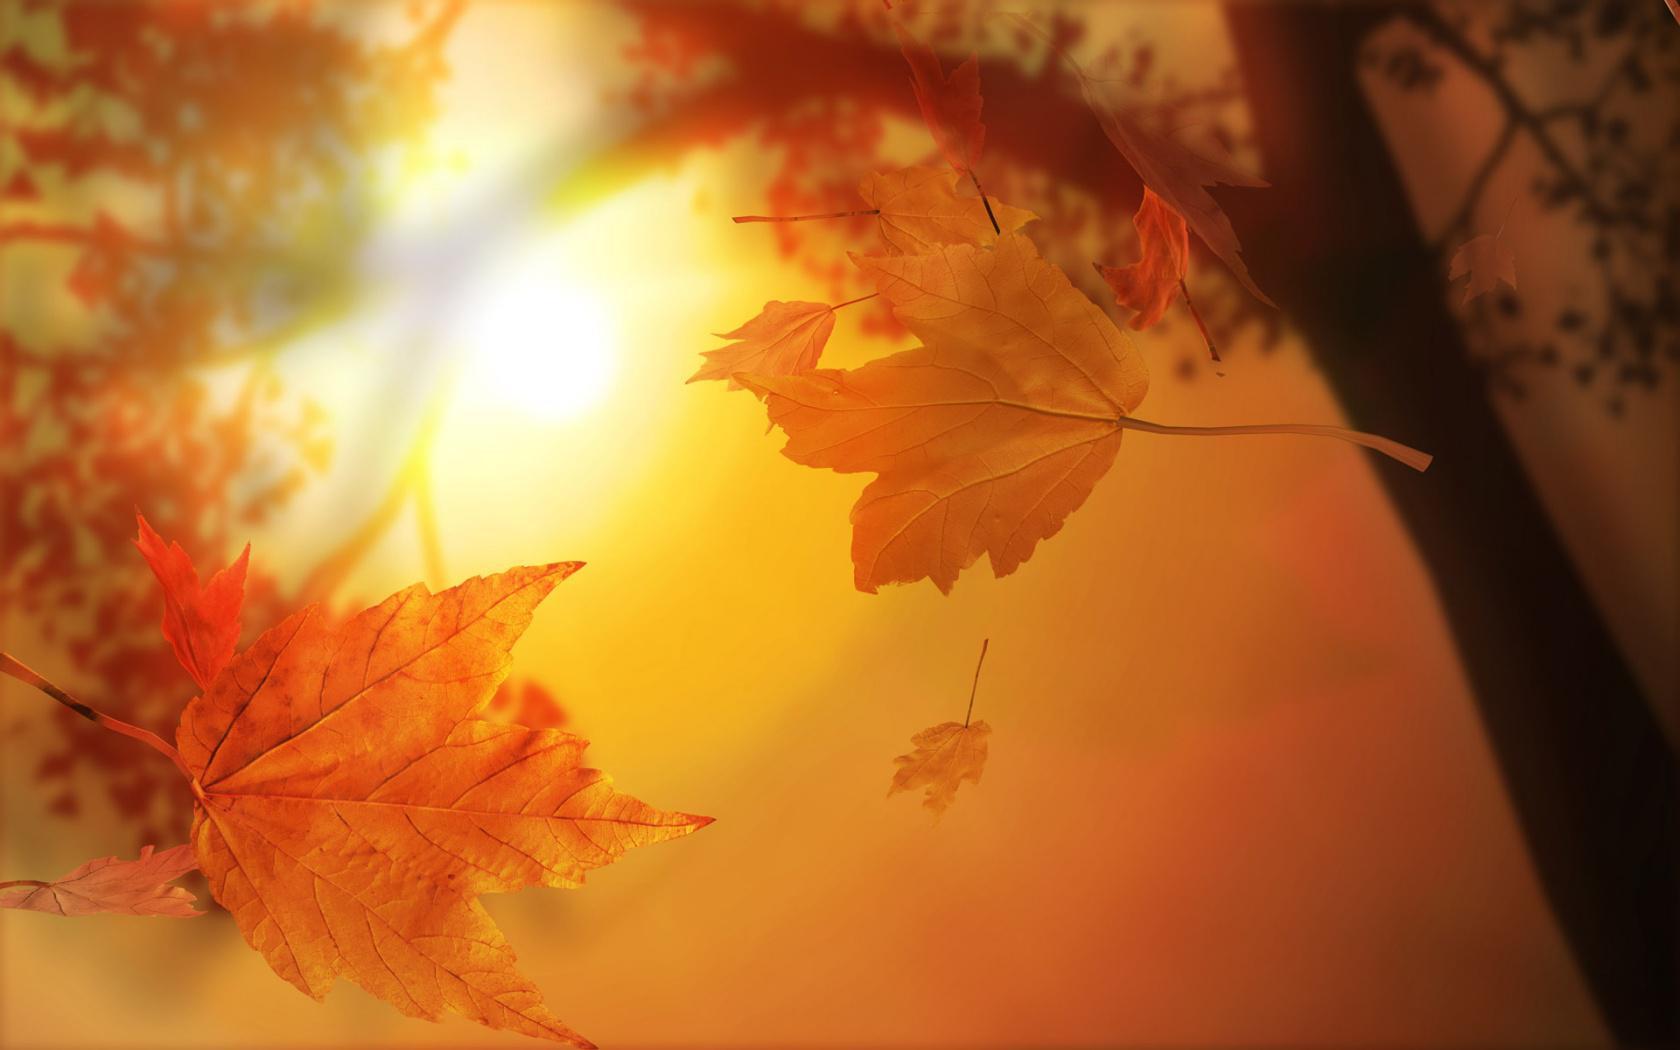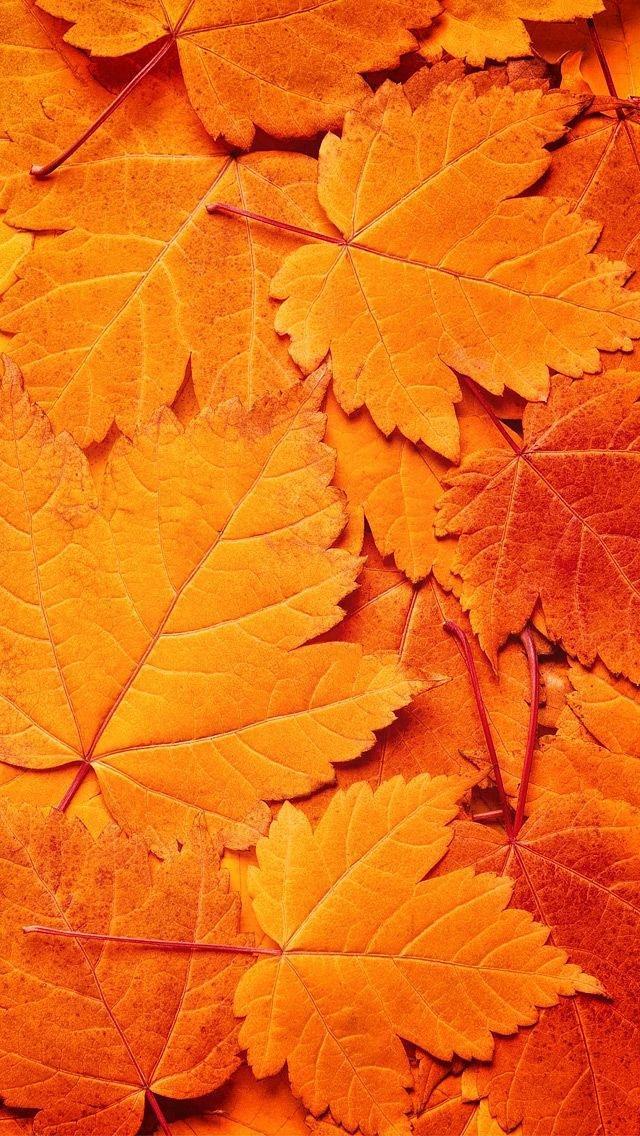The first image is the image on the left, the second image is the image on the right. Assess this claim about the two images: "The right image shows a bunch of autumn leaves shaped like maple leaves.". Correct or not? Answer yes or no. Yes. 